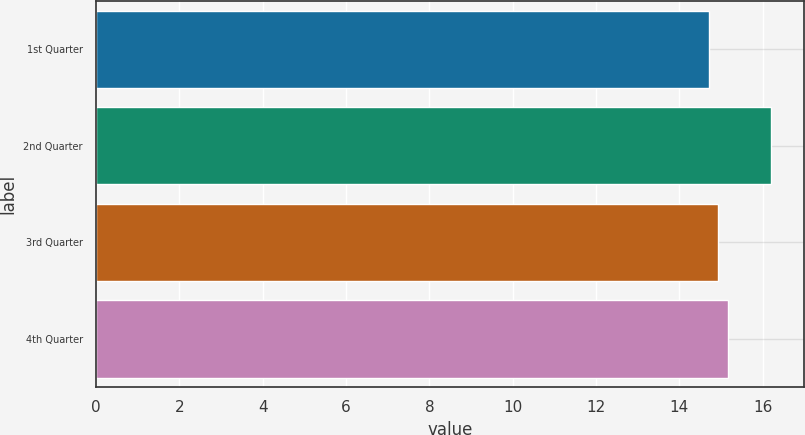<chart> <loc_0><loc_0><loc_500><loc_500><bar_chart><fcel>1st Quarter<fcel>2nd Quarter<fcel>3rd Quarter<fcel>4th Quarter<nl><fcel>14.7<fcel>16.19<fcel>14.92<fcel>15.16<nl></chart> 